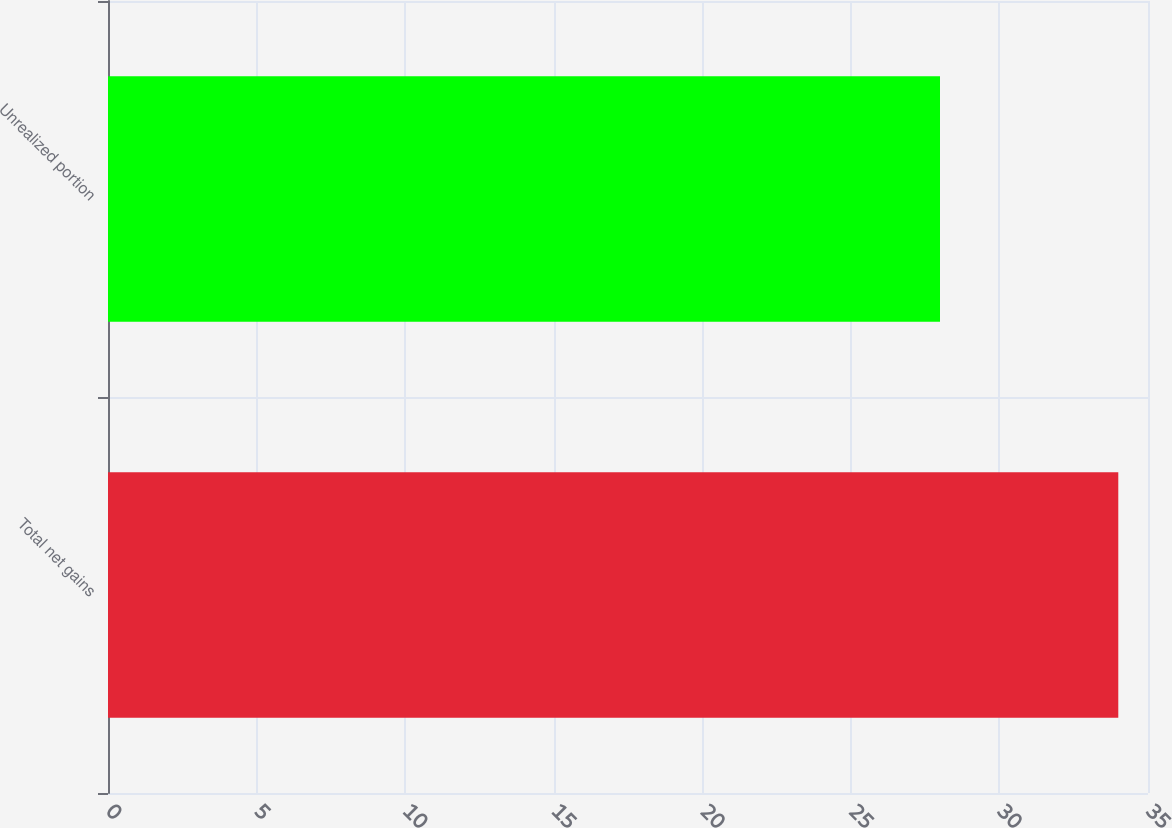Convert chart. <chart><loc_0><loc_0><loc_500><loc_500><bar_chart><fcel>Total net gains<fcel>Unrealized portion<nl><fcel>34<fcel>28<nl></chart> 